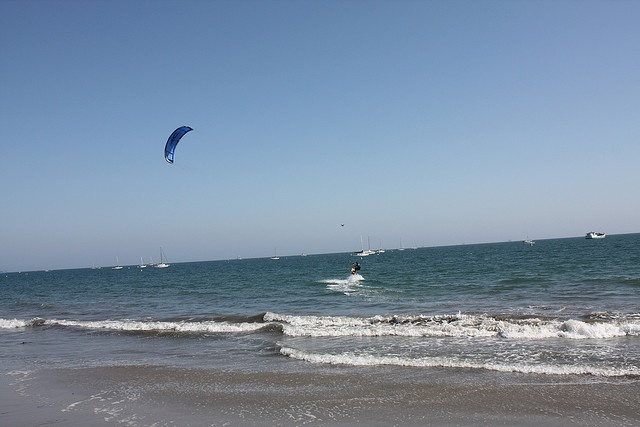Describe the objects in this image and their specific colors. I can see kite in gray, navy, blue, black, and lightblue tones, boat in gray, white, blue, and black tones, boat in gray, darkgray, and lightgray tones, boat in gray, darkgray, lightgray, and blue tones, and boat in gray, darkgray, blue, and white tones in this image. 